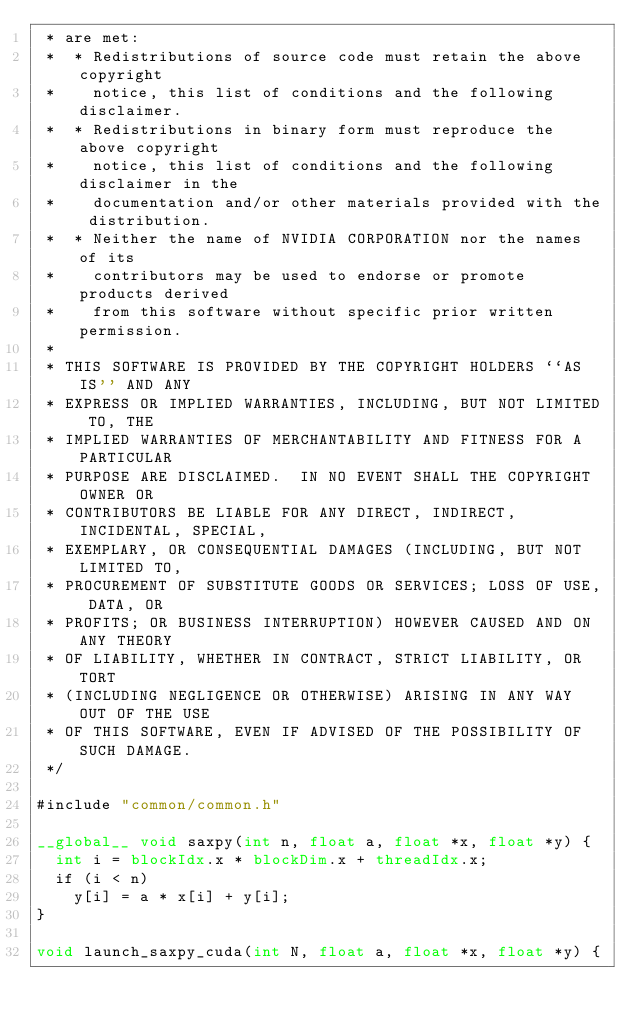<code> <loc_0><loc_0><loc_500><loc_500><_Cuda_> * are met:
 *  * Redistributions of source code must retain the above copyright
 *    notice, this list of conditions and the following disclaimer.
 *  * Redistributions in binary form must reproduce the above copyright
 *    notice, this list of conditions and the following disclaimer in the
 *    documentation and/or other materials provided with the distribution.
 *  * Neither the name of NVIDIA CORPORATION nor the names of its
 *    contributors may be used to endorse or promote products derived
 *    from this software without specific prior written permission.
 *
 * THIS SOFTWARE IS PROVIDED BY THE COPYRIGHT HOLDERS ``AS IS'' AND ANY
 * EXPRESS OR IMPLIED WARRANTIES, INCLUDING, BUT NOT LIMITED TO, THE
 * IMPLIED WARRANTIES OF MERCHANTABILITY AND FITNESS FOR A PARTICULAR
 * PURPOSE ARE DISCLAIMED.  IN NO EVENT SHALL THE COPYRIGHT OWNER OR
 * CONTRIBUTORS BE LIABLE FOR ANY DIRECT, INDIRECT, INCIDENTAL, SPECIAL,
 * EXEMPLARY, OR CONSEQUENTIAL DAMAGES (INCLUDING, BUT NOT LIMITED TO,
 * PROCUREMENT OF SUBSTITUTE GOODS OR SERVICES; LOSS OF USE, DATA, OR
 * PROFITS; OR BUSINESS INTERRUPTION) HOWEVER CAUSED AND ON ANY THEORY
 * OF LIABILITY, WHETHER IN CONTRACT, STRICT LIABILITY, OR TORT
 * (INCLUDING NEGLIGENCE OR OTHERWISE) ARISING IN ANY WAY OUT OF THE USE
 * OF THIS SOFTWARE, EVEN IF ADVISED OF THE POSSIBILITY OF SUCH DAMAGE.
 */

#include "common/common.h"

__global__ void saxpy(int n, float a, float *x, float *y) {
  int i = blockIdx.x * blockDim.x + threadIdx.x;
  if (i < n)
    y[i] = a * x[i] + y[i];
}

void launch_saxpy_cuda(int N, float a, float *x, float *y) {</code> 